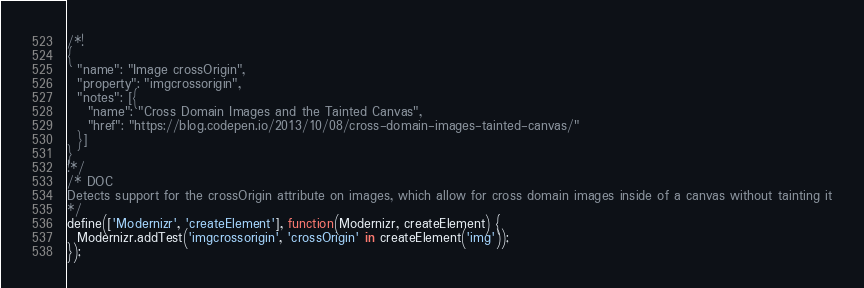<code> <loc_0><loc_0><loc_500><loc_500><_JavaScript_>/*!
{
  "name": "Image crossOrigin",
  "property": "imgcrossorigin",
  "notes": [{
    "name": "Cross Domain Images and the Tainted Canvas",
    "href": "https://blog.codepen.io/2013/10/08/cross-domain-images-tainted-canvas/"
  }]
}
!*/
/* DOC
Detects support for the crossOrigin attribute on images, which allow for cross domain images inside of a canvas without tainting it
*/
define(['Modernizr', 'createElement'], function(Modernizr, createElement) {
  Modernizr.addTest('imgcrossorigin', 'crossOrigin' in createElement('img'));
});
</code> 